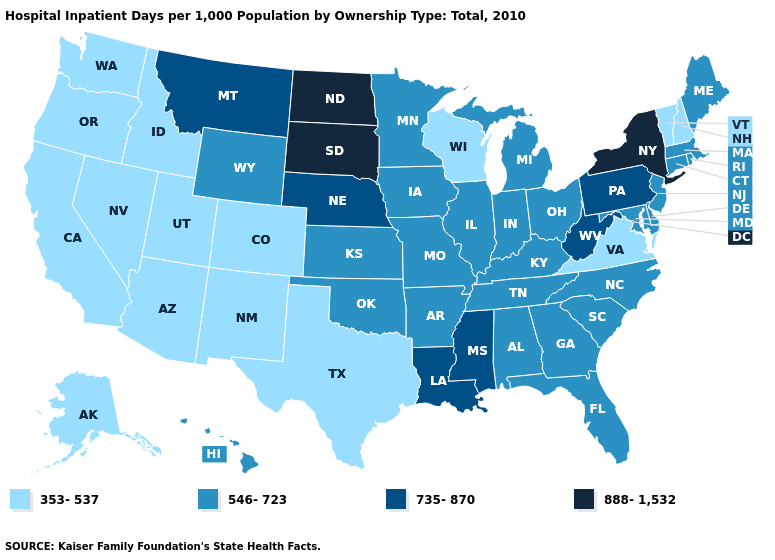Which states have the lowest value in the South?
Answer briefly. Texas, Virginia. Name the states that have a value in the range 353-537?
Quick response, please. Alaska, Arizona, California, Colorado, Idaho, Nevada, New Hampshire, New Mexico, Oregon, Texas, Utah, Vermont, Virginia, Washington, Wisconsin. What is the value of New Mexico?
Give a very brief answer. 353-537. Does New Hampshire have a lower value than Wisconsin?
Be succinct. No. What is the value of Pennsylvania?
Quick response, please. 735-870. What is the value of Hawaii?
Answer briefly. 546-723. Which states have the highest value in the USA?
Be succinct. New York, North Dakota, South Dakota. What is the highest value in the USA?
Give a very brief answer. 888-1,532. Does Mississippi have a lower value than Arizona?
Give a very brief answer. No. What is the lowest value in states that border Michigan?
Keep it brief. 353-537. Does the map have missing data?
Short answer required. No. Name the states that have a value in the range 735-870?
Short answer required. Louisiana, Mississippi, Montana, Nebraska, Pennsylvania, West Virginia. Name the states that have a value in the range 735-870?
Be succinct. Louisiana, Mississippi, Montana, Nebraska, Pennsylvania, West Virginia. 